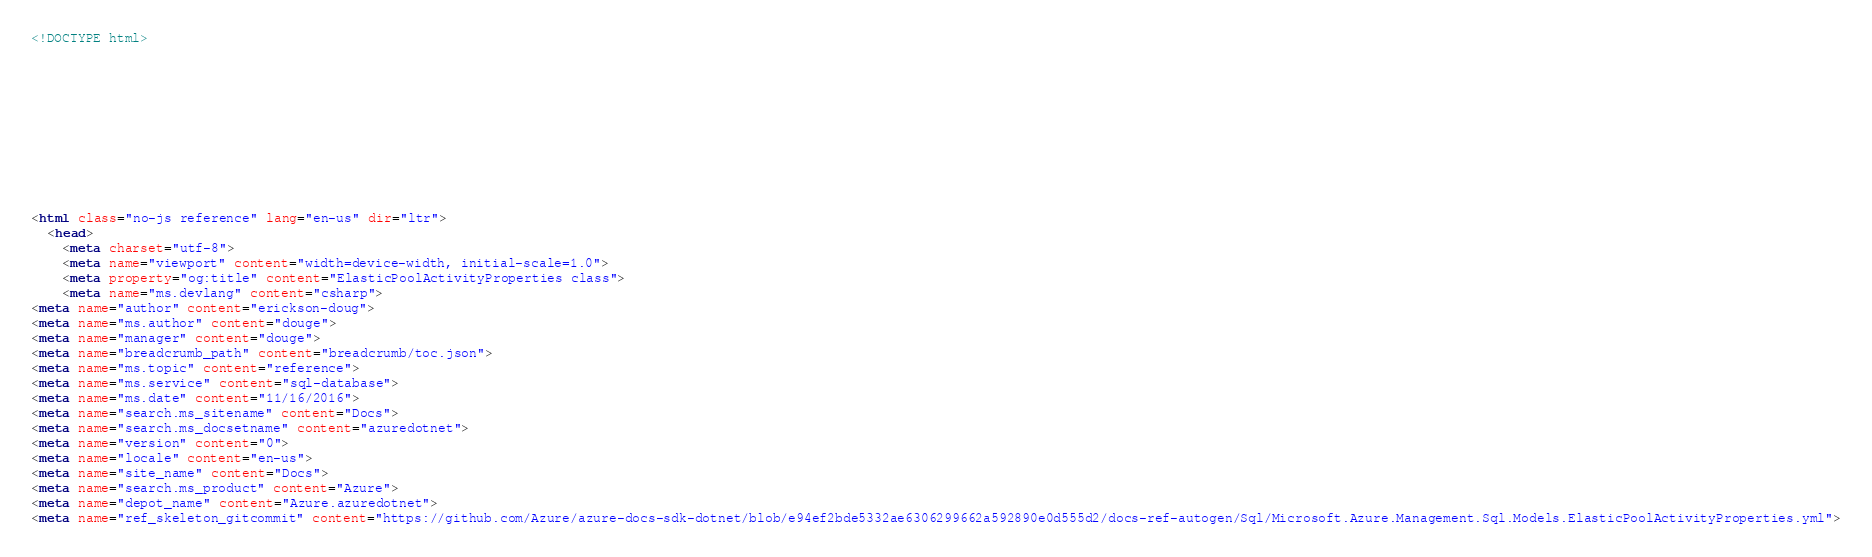Convert code to text. <code><loc_0><loc_0><loc_500><loc_500><_HTML_><!DOCTYPE html>



  


  


  

<html class="no-js reference" lang="en-us" dir="ltr">
  <head>
    <meta charset="utf-8">
    <meta name="viewport" content="width=device-width, initial-scale=1.0">
    <meta property="og:title" content="ElasticPoolActivityProperties class">
    <meta name="ms.devlang" content="csharp">
<meta name="author" content="erickson-doug">
<meta name="ms.author" content="douge">
<meta name="manager" content="douge">
<meta name="breadcrumb_path" content="breadcrumb/toc.json">
<meta name="ms.topic" content="reference">
<meta name="ms.service" content="sql-database">
<meta name="ms.date" content="11/16/2016">
<meta name="search.ms_sitename" content="Docs">
<meta name="search.ms_docsetname" content="azuredotnet">
<meta name="version" content="0">
<meta name="locale" content="en-us">
<meta name="site_name" content="Docs">
<meta name="search.ms_product" content="Azure">
<meta name="depot_name" content="Azure.azuredotnet">
<meta name="ref_skeleton_gitcommit" content="https://github.com/Azure/azure-docs-sdk-dotnet/blob/e94ef2bde5332ae6306299662a592890e0d555d2/docs-ref-autogen/Sql/Microsoft.Azure.Management.Sql.Models.ElasticPoolActivityProperties.yml"></code> 